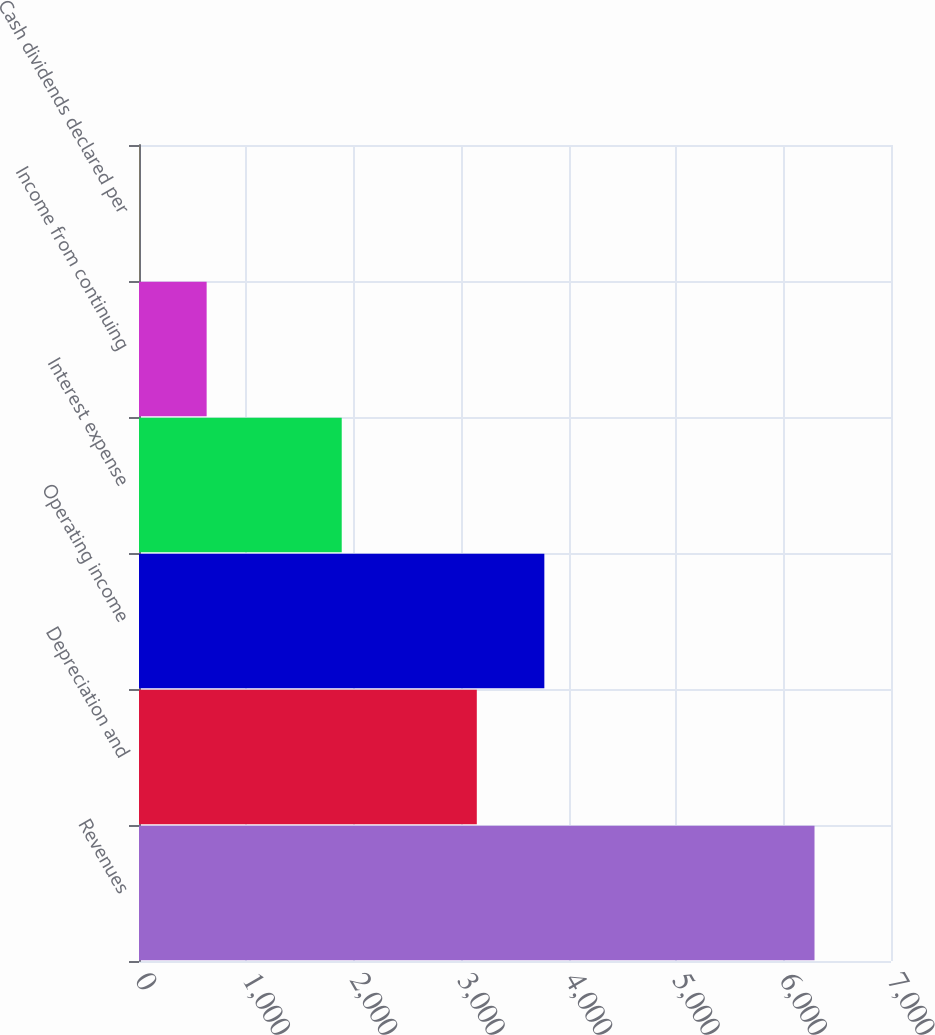Convert chart. <chart><loc_0><loc_0><loc_500><loc_500><bar_chart><fcel>Revenues<fcel>Depreciation and<fcel>Operating income<fcel>Interest expense<fcel>Income from continuing<fcel>Cash dividends declared per<nl><fcel>6288<fcel>3144.49<fcel>3773.19<fcel>1887.07<fcel>629.66<fcel>0.95<nl></chart> 